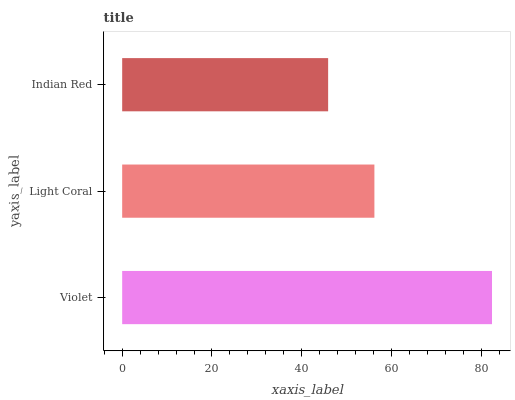Is Indian Red the minimum?
Answer yes or no. Yes. Is Violet the maximum?
Answer yes or no. Yes. Is Light Coral the minimum?
Answer yes or no. No. Is Light Coral the maximum?
Answer yes or no. No. Is Violet greater than Light Coral?
Answer yes or no. Yes. Is Light Coral less than Violet?
Answer yes or no. Yes. Is Light Coral greater than Violet?
Answer yes or no. No. Is Violet less than Light Coral?
Answer yes or no. No. Is Light Coral the high median?
Answer yes or no. Yes. Is Light Coral the low median?
Answer yes or no. Yes. Is Indian Red the high median?
Answer yes or no. No. Is Violet the low median?
Answer yes or no. No. 